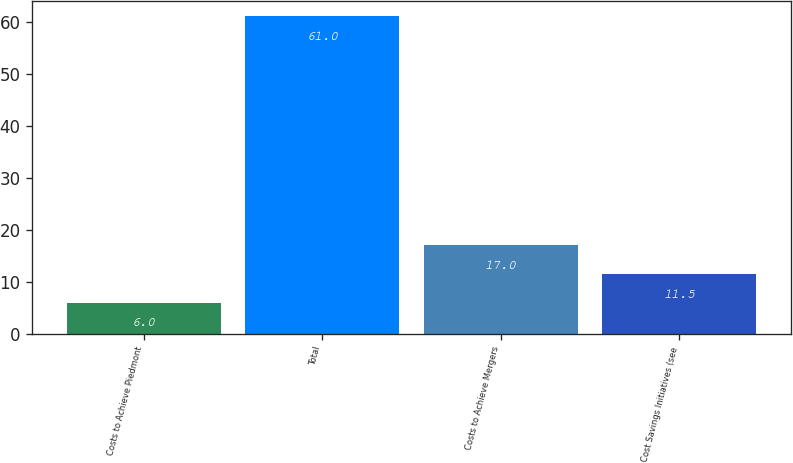Convert chart. <chart><loc_0><loc_0><loc_500><loc_500><bar_chart><fcel>Costs to Achieve Piedmont<fcel>Total<fcel>Costs to Achieve Mergers<fcel>Cost Savings Initiatives (see<nl><fcel>6<fcel>61<fcel>17<fcel>11.5<nl></chart> 